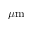Convert formula to latex. <formula><loc_0><loc_0><loc_500><loc_500>\mu m</formula> 